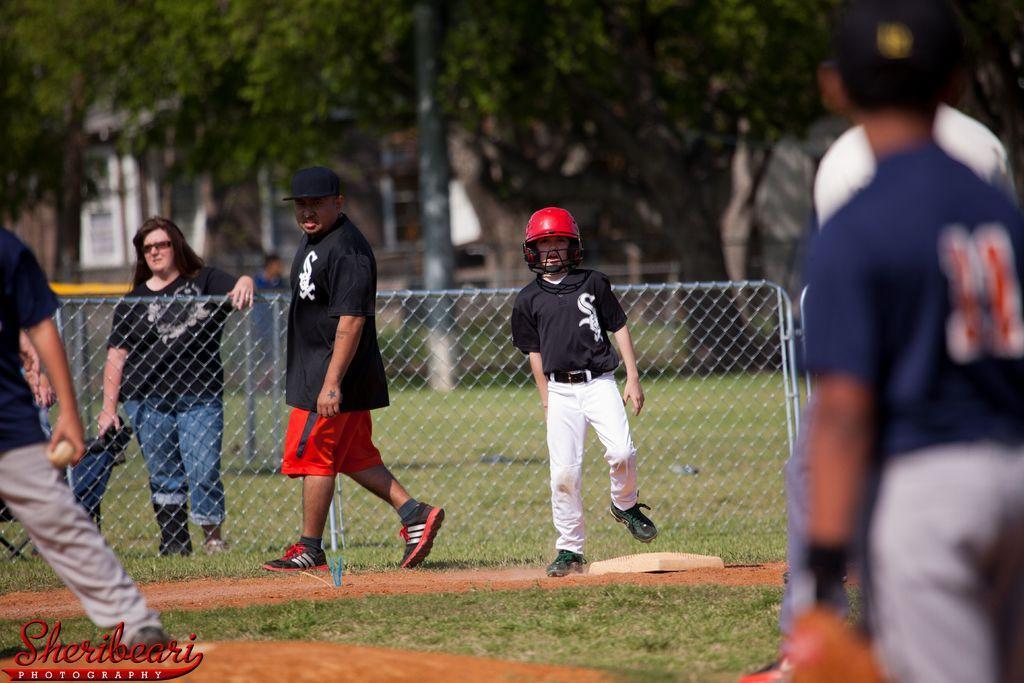Describe this image in one or two sentences. In this picture we can see a group of people where some are standing and some are walking on the ground, fence, trees, building with windows, pole. 